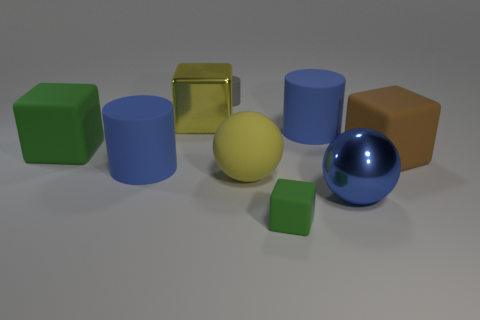Subtract all big shiny cubes. How many cubes are left? 3 Subtract all brown cubes. How many blue cylinders are left? 2 Subtract all yellow blocks. How many blocks are left? 3 Subtract 2 blocks. How many blocks are left? 2 Add 1 small gray objects. How many objects exist? 10 Subtract all red cubes. Subtract all brown cylinders. How many cubes are left? 4 Subtract all cubes. How many objects are left? 5 Add 6 tiny things. How many tiny things exist? 8 Subtract 0 yellow cylinders. How many objects are left? 9 Subtract all large green objects. Subtract all blue objects. How many objects are left? 5 